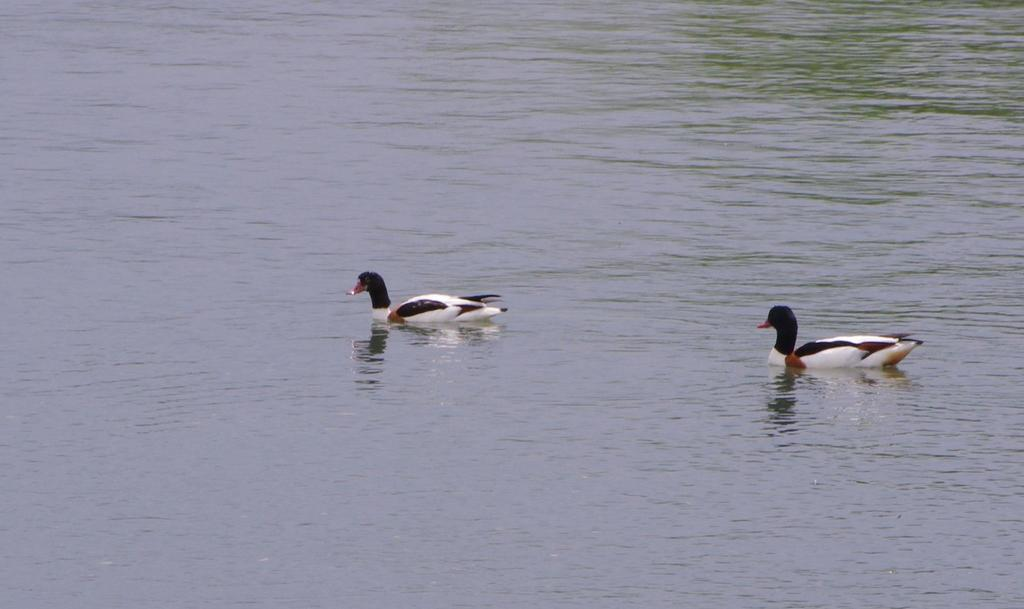What is located in the center of the image? There are birds in the center of the image. Where are the birds situated? The birds are on the water. What type of property can be seen in the background of the image? There is no property visible in the image; it features birds on the water. Can you tell me how many snails are swimming with the birds in the image? There are no snails present in the image; it only features birds on the water. 